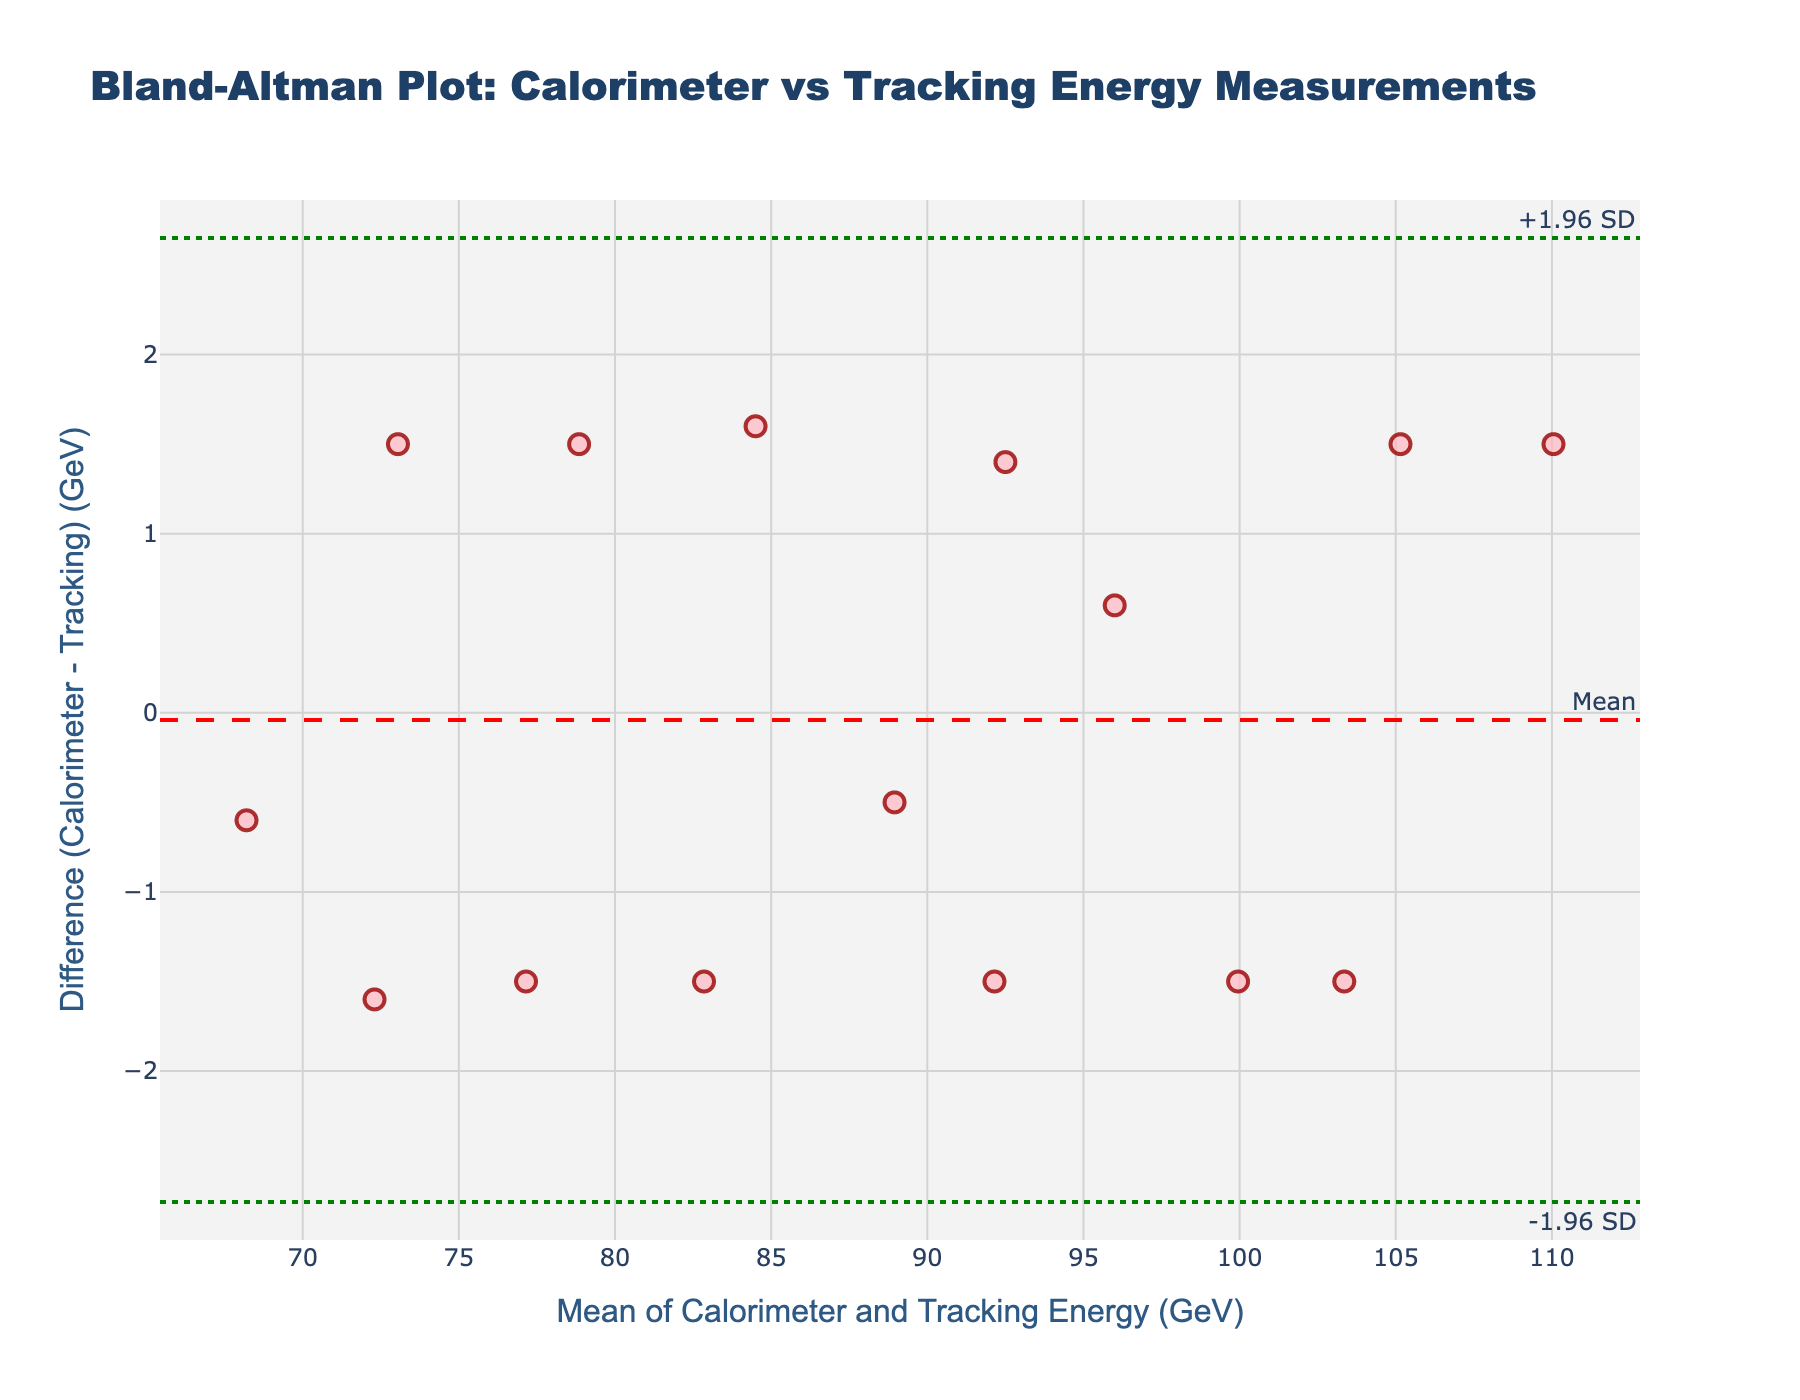what is the title of the plot? The title of the plot is usually displayed at the top in a larger or bolder font. The title of this plot is "Bland-Altman Plot: Calorimeter vs Tracking Energy Measurements".
Answer: Bland-Altman Plot: Calorimeter vs Tracking Energy Measurements what do the x-axis and y-axis represent in the plot? The x-axis and y-axis usually have labels indicating the type of data they represent. In this plot, the x-axis is labeled "Mean of Calorimeter and Tracking Energy (GeV)" and the y-axis is labeled "Difference (Calorimeter - Tracking) (GeV)".
Answer: Mean of Calorimeter and Tracking Energy (GeV), Difference (Calorimeter - Tracking) (GeV) how many data points are plotted? Each data point is represented by a marker in the plot. By counting the markers, we can see that there are 15 data points plotted.
Answer: 15 what is the mean difference between calorimeter and tracking measurements? The mean difference is represented by a dashed line on the plot and usually labeled. In this plot, the red dashed line represents the mean difference, which is 0.1 GeV.
Answer: 0.1 GeV what are the upper and lower limits of agreement? The limits of agreement are often lines on the plot with specific labels. Here, the upper and lower limits of agreement are represented by green dotted lines at +1.96 SD and -1.96 SD, which are approximately 1.755 GeV and -1.555 GeV, respectively.
Answer: 1.755 GeV, -1.555 GeV which measurement method tends to give higher energy readings on average, calorimeter or tracking? By observing the y-axis, if the majority of points lie above the zero line, it indicates that the calorimeter measurements are higher. And this plot shows most points above the zero line, indicating that on average, calorimeter measurements tend to give higher energy readings than tracking measurements.
Answer: Calorimeter what is the range of the means of calorimeter and tracking measurements? The range of the means can be found by looking at the x-axis values. The mean values vary from approximately 69.7 GeV to 103.1 GeV.
Answer: 69.7 GeV to 103.1 GeV are there any outliers in the difference values? Outliers are points that are notably distant from others. In the context of limits of agreement, any data point beyond the upper and lower limits (1.755 GeV and -1.555 GeV) could be considered outliers. In this plot, there are no points beyond these limits.
Answer: No 